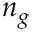Convert formula to latex. <formula><loc_0><loc_0><loc_500><loc_500>n _ { g }</formula> 